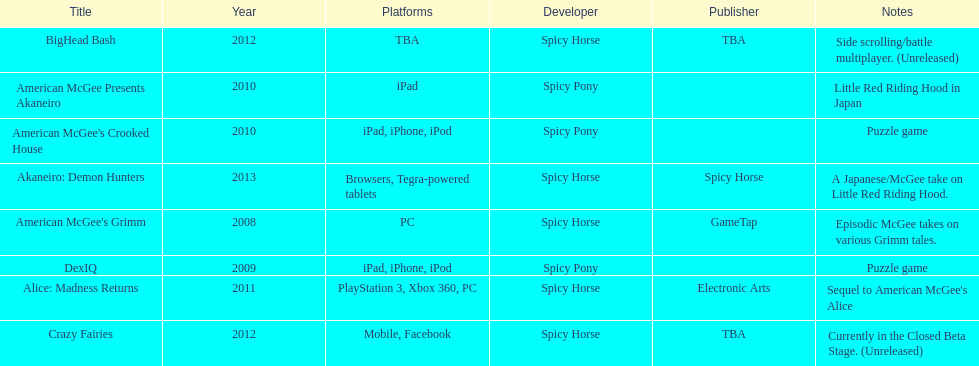What was the last game created by spicy horse Akaneiro: Demon Hunters. 